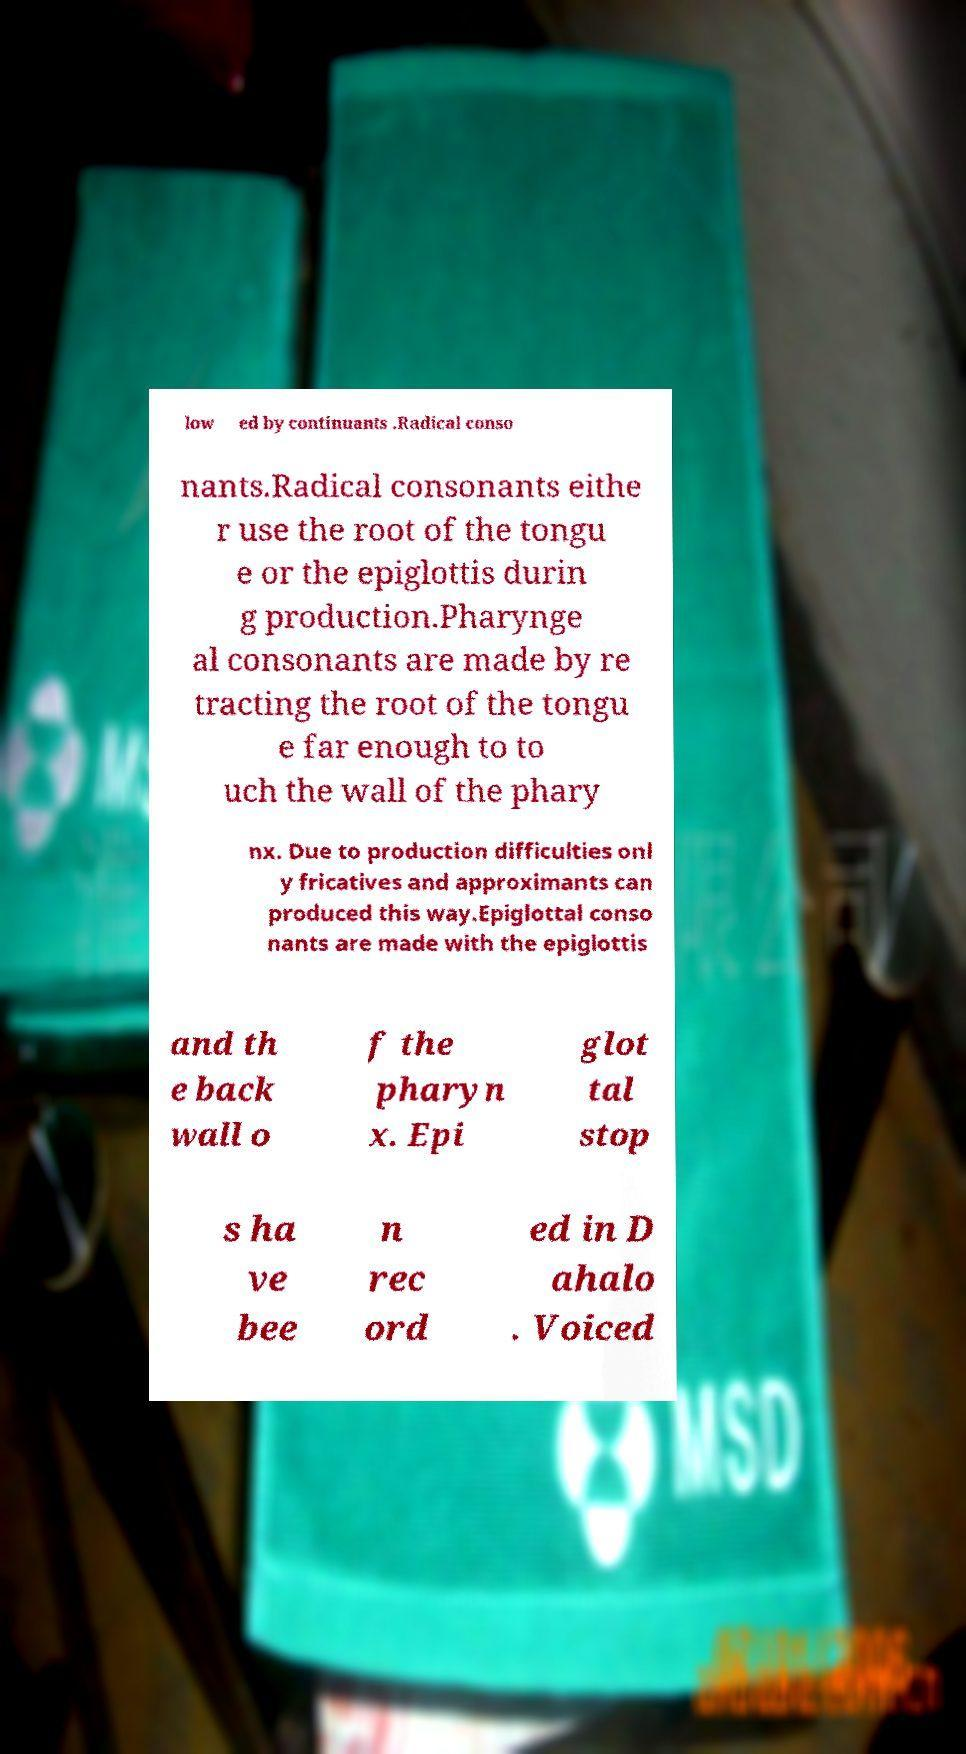What messages or text are displayed in this image? I need them in a readable, typed format. low ed by continuants .Radical conso nants.Radical consonants eithe r use the root of the tongu e or the epiglottis durin g production.Pharynge al consonants are made by re tracting the root of the tongu e far enough to to uch the wall of the phary nx. Due to production difficulties onl y fricatives and approximants can produced this way.Epiglottal conso nants are made with the epiglottis and th e back wall o f the pharyn x. Epi glot tal stop s ha ve bee n rec ord ed in D ahalo . Voiced 